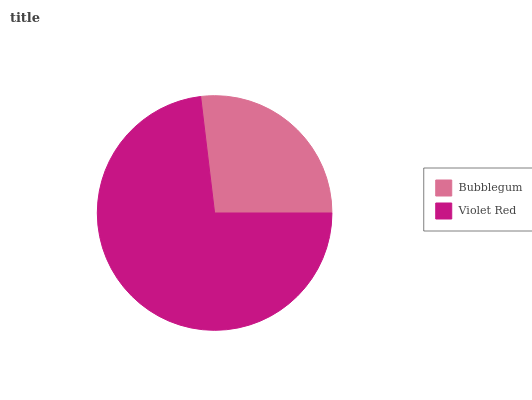Is Bubblegum the minimum?
Answer yes or no. Yes. Is Violet Red the maximum?
Answer yes or no. Yes. Is Violet Red the minimum?
Answer yes or no. No. Is Violet Red greater than Bubblegum?
Answer yes or no. Yes. Is Bubblegum less than Violet Red?
Answer yes or no. Yes. Is Bubblegum greater than Violet Red?
Answer yes or no. No. Is Violet Red less than Bubblegum?
Answer yes or no. No. Is Violet Red the high median?
Answer yes or no. Yes. Is Bubblegum the low median?
Answer yes or no. Yes. Is Bubblegum the high median?
Answer yes or no. No. Is Violet Red the low median?
Answer yes or no. No. 